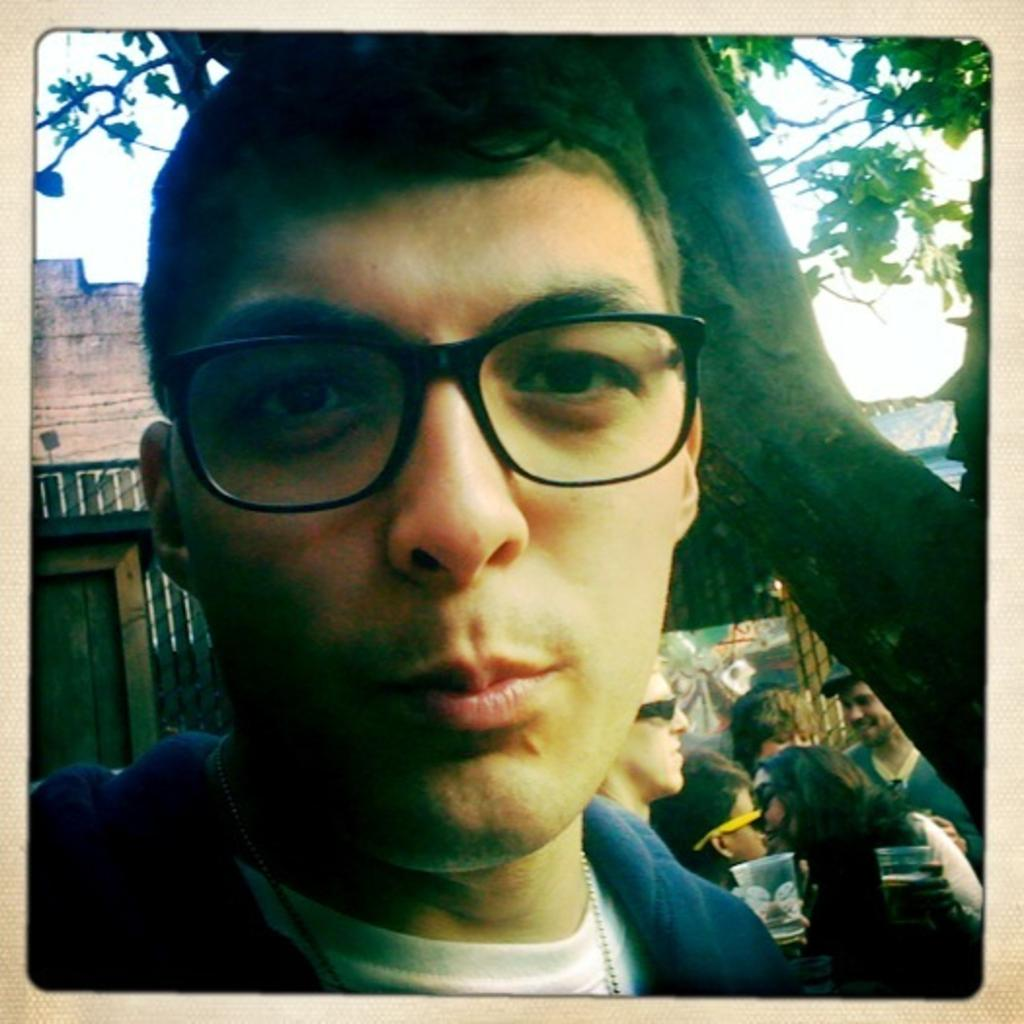What is the person in the foreground of the image wearing? The person in the image is wearing spectacles. What can be seen in the background of the image? In the background of the image, there are people, houses, glasses, a tree, the sky, and other objects. How many people are visible in the image? There is one person in the foreground and multiple people in the background, so the total number of people is not specified. What type of shoes is the person wearing in the image? The provided facts do not mention any shoes being worn by the person in the image. --- Facts: 1. There is a person holding a book in the image. 2. The person is sitting on a chair. 3. There is a table in the image. 4. The table has a lamp on it. 5. There is a window in the background of the image. 6. The sky is visible through the window. Absurd Topics: parrot, bicycle, fence Conversation: What is the person holding in the image? The person is holding a book in the image. What is the person sitting on in the image? The person is sitting on a chair in the image. What can be seen on the table in the image? There is a lamp on the table in the image. What is visible in the background of the image? In the background of the image, there is a window and the sky is visible through it. Reasoning: Let's think step by step in order to produce the conversation. We start by identifying the main subject in the image, which is the person holding a book. Then, we expand the conversation to include the person's seating arrangement and the objects on the table. Finally, we describe the background of the image, which contains a window and the sky. Each question is designed to elicit a specific detail about the image that is known from the provided facts. Absurd Question/Answer: What type of parrot can be seen sitting on the bicycle in the image? There is no parrot or bicycle present in the image. 